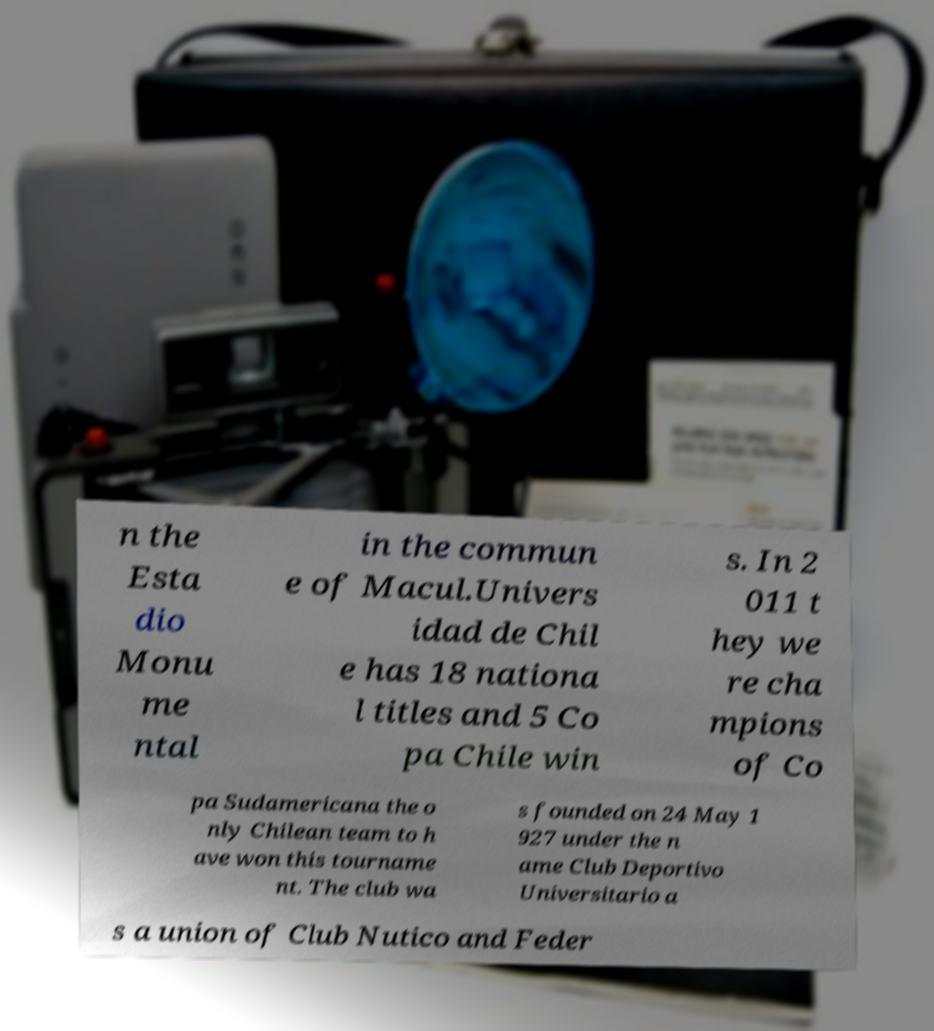What messages or text are displayed in this image? I need them in a readable, typed format. n the Esta dio Monu me ntal in the commun e of Macul.Univers idad de Chil e has 18 nationa l titles and 5 Co pa Chile win s. In 2 011 t hey we re cha mpions of Co pa Sudamericana the o nly Chilean team to h ave won this tourname nt. The club wa s founded on 24 May 1 927 under the n ame Club Deportivo Universitario a s a union of Club Nutico and Feder 